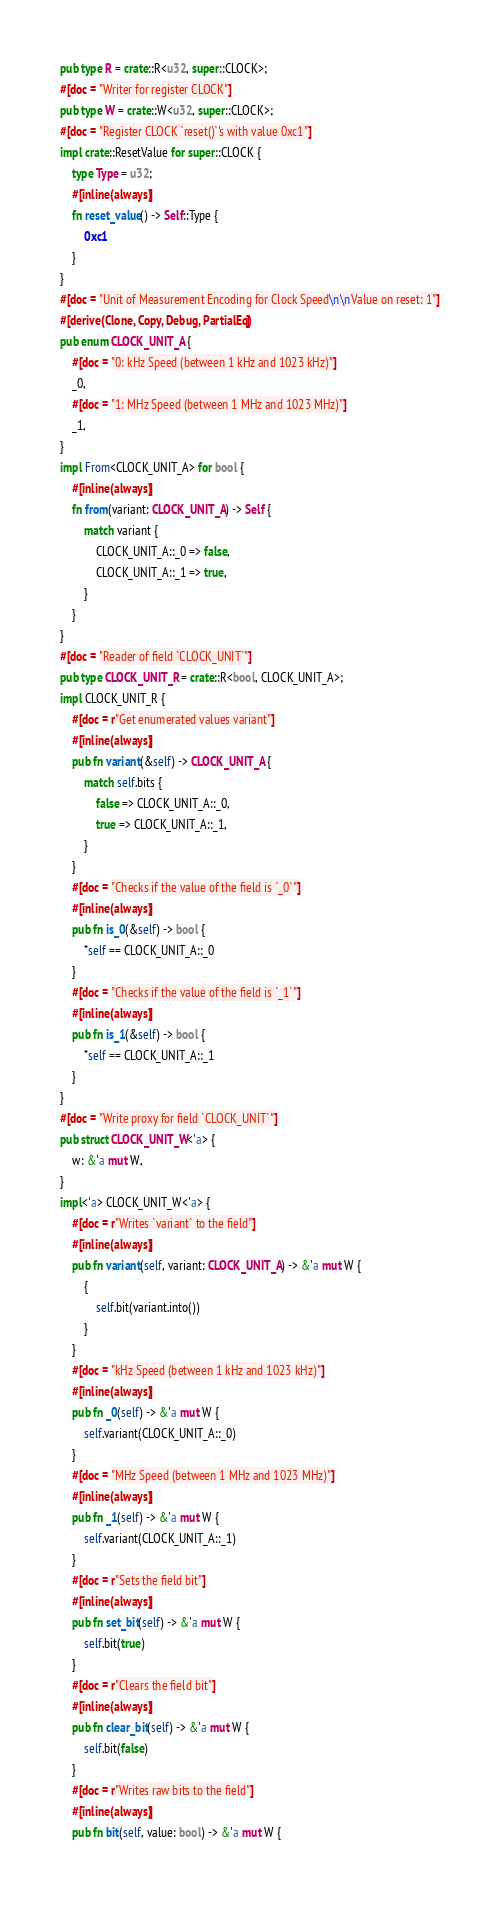Convert code to text. <code><loc_0><loc_0><loc_500><loc_500><_Rust_>pub type R = crate::R<u32, super::CLOCK>;
#[doc = "Writer for register CLOCK"]
pub type W = crate::W<u32, super::CLOCK>;
#[doc = "Register CLOCK `reset()`'s with value 0xc1"]
impl crate::ResetValue for super::CLOCK {
    type Type = u32;
    #[inline(always)]
    fn reset_value() -> Self::Type {
        0xc1
    }
}
#[doc = "Unit of Measurement Encoding for Clock Speed\n\nValue on reset: 1"]
#[derive(Clone, Copy, Debug, PartialEq)]
pub enum CLOCK_UNIT_A {
    #[doc = "0: kHz Speed (between 1 kHz and 1023 kHz)"]
    _0,
    #[doc = "1: MHz Speed (between 1 MHz and 1023 MHz)"]
    _1,
}
impl From<CLOCK_UNIT_A> for bool {
    #[inline(always)]
    fn from(variant: CLOCK_UNIT_A) -> Self {
        match variant {
            CLOCK_UNIT_A::_0 => false,
            CLOCK_UNIT_A::_1 => true,
        }
    }
}
#[doc = "Reader of field `CLOCK_UNIT`"]
pub type CLOCK_UNIT_R = crate::R<bool, CLOCK_UNIT_A>;
impl CLOCK_UNIT_R {
    #[doc = r"Get enumerated values variant"]
    #[inline(always)]
    pub fn variant(&self) -> CLOCK_UNIT_A {
        match self.bits {
            false => CLOCK_UNIT_A::_0,
            true => CLOCK_UNIT_A::_1,
        }
    }
    #[doc = "Checks if the value of the field is `_0`"]
    #[inline(always)]
    pub fn is_0(&self) -> bool {
        *self == CLOCK_UNIT_A::_0
    }
    #[doc = "Checks if the value of the field is `_1`"]
    #[inline(always)]
    pub fn is_1(&self) -> bool {
        *self == CLOCK_UNIT_A::_1
    }
}
#[doc = "Write proxy for field `CLOCK_UNIT`"]
pub struct CLOCK_UNIT_W<'a> {
    w: &'a mut W,
}
impl<'a> CLOCK_UNIT_W<'a> {
    #[doc = r"Writes `variant` to the field"]
    #[inline(always)]
    pub fn variant(self, variant: CLOCK_UNIT_A) -> &'a mut W {
        {
            self.bit(variant.into())
        }
    }
    #[doc = "kHz Speed (between 1 kHz and 1023 kHz)"]
    #[inline(always)]
    pub fn _0(self) -> &'a mut W {
        self.variant(CLOCK_UNIT_A::_0)
    }
    #[doc = "MHz Speed (between 1 MHz and 1023 MHz)"]
    #[inline(always)]
    pub fn _1(self) -> &'a mut W {
        self.variant(CLOCK_UNIT_A::_1)
    }
    #[doc = r"Sets the field bit"]
    #[inline(always)]
    pub fn set_bit(self) -> &'a mut W {
        self.bit(true)
    }
    #[doc = r"Clears the field bit"]
    #[inline(always)]
    pub fn clear_bit(self) -> &'a mut W {
        self.bit(false)
    }
    #[doc = r"Writes raw bits to the field"]
    #[inline(always)]
    pub fn bit(self, value: bool) -> &'a mut W {</code> 